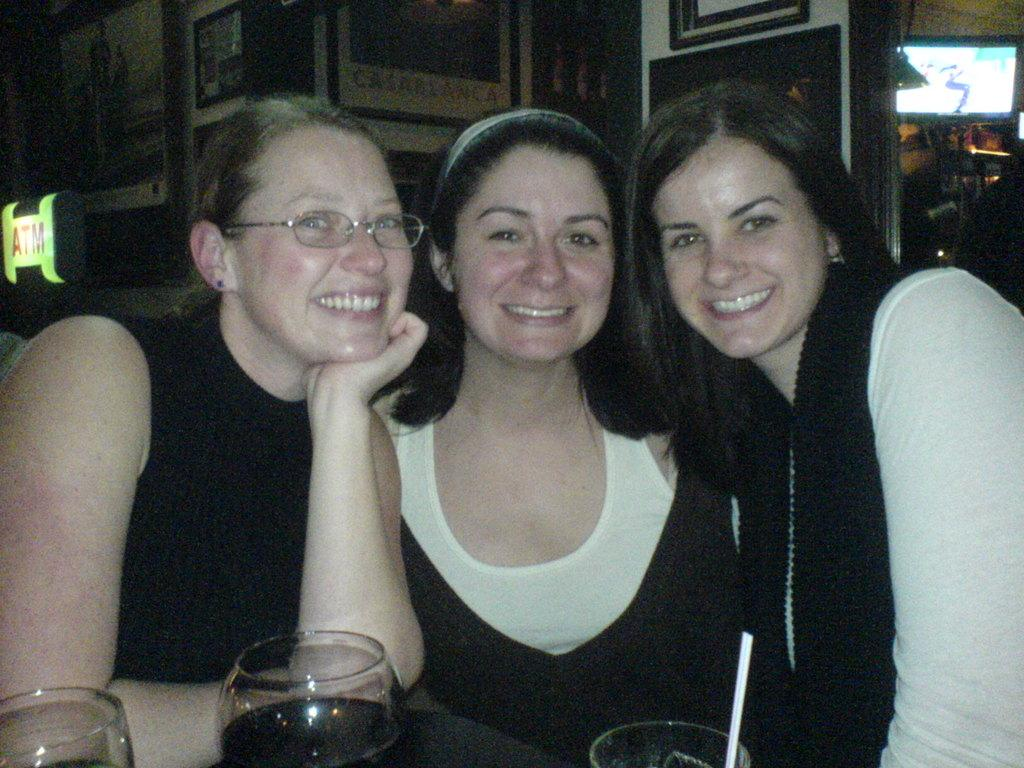How many people are in the image? There are three people in the image. What is the facial expression of the people in the image? The people are smiling. What objects are in front of the people? There are three glasses in front of the people. What can be seen on the wall in the image? There are pictures on the wall. What is the purpose of the board in the image? The purpose of the board is not specified, but it is present in the image. What electronic device is visible in the image? There is a television in the image. What type of activity are the dogs participating in with the people in the image? There are no dogs present in the image, so it is not possible to answer that question. 